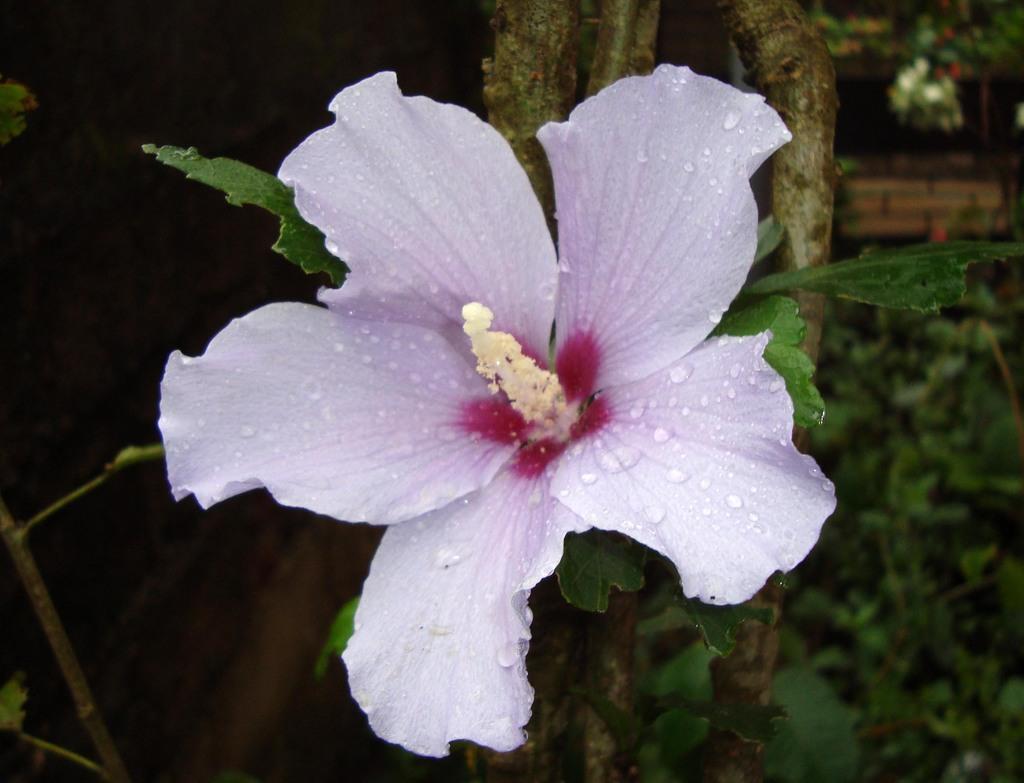Can you describe this image briefly? In this image we can see a hibiscus flower. In the background it is looking blur and green. 